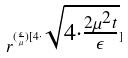Convert formula to latex. <formula><loc_0><loc_0><loc_500><loc_500>r ^ { ( \frac { \epsilon } { \mu } ) [ 4 \cdot \sqrt { 4 \cdot \frac { 2 \mu ^ { 2 } t } { \epsilon } } ] }</formula> 